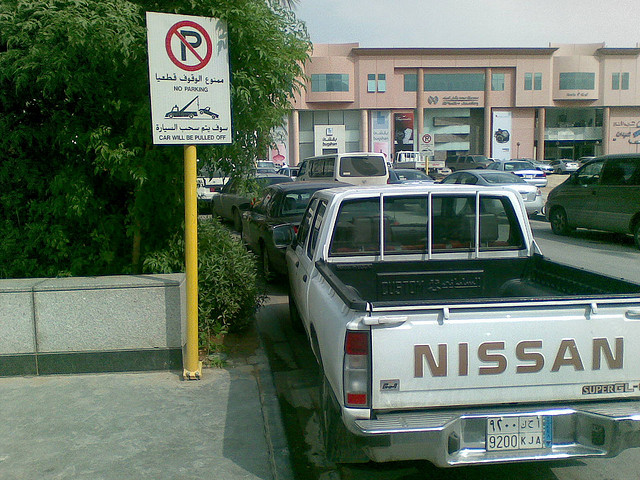How many cars can be seen? It's challenging to provide an exact number. The photo shows a parking area with one clearly visible Nissan truck, but there are multiple vehicles in the background which are not fully visible. 